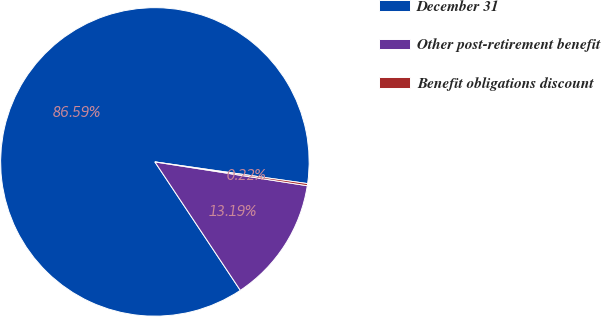Convert chart. <chart><loc_0><loc_0><loc_500><loc_500><pie_chart><fcel>December 31<fcel>Other post-retirement benefit<fcel>Benefit obligations discount<nl><fcel>86.58%<fcel>13.19%<fcel>0.22%<nl></chart> 